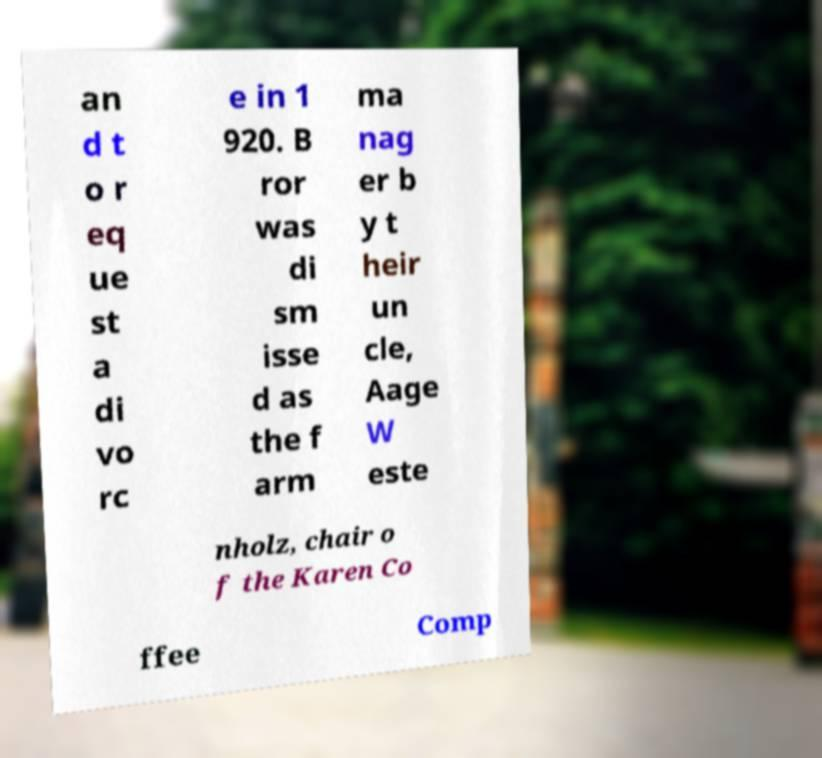There's text embedded in this image that I need extracted. Can you transcribe it verbatim? an d t o r eq ue st a di vo rc e in 1 920. B ror was di sm isse d as the f arm ma nag er b y t heir un cle, Aage W este nholz, chair o f the Karen Co ffee Comp 